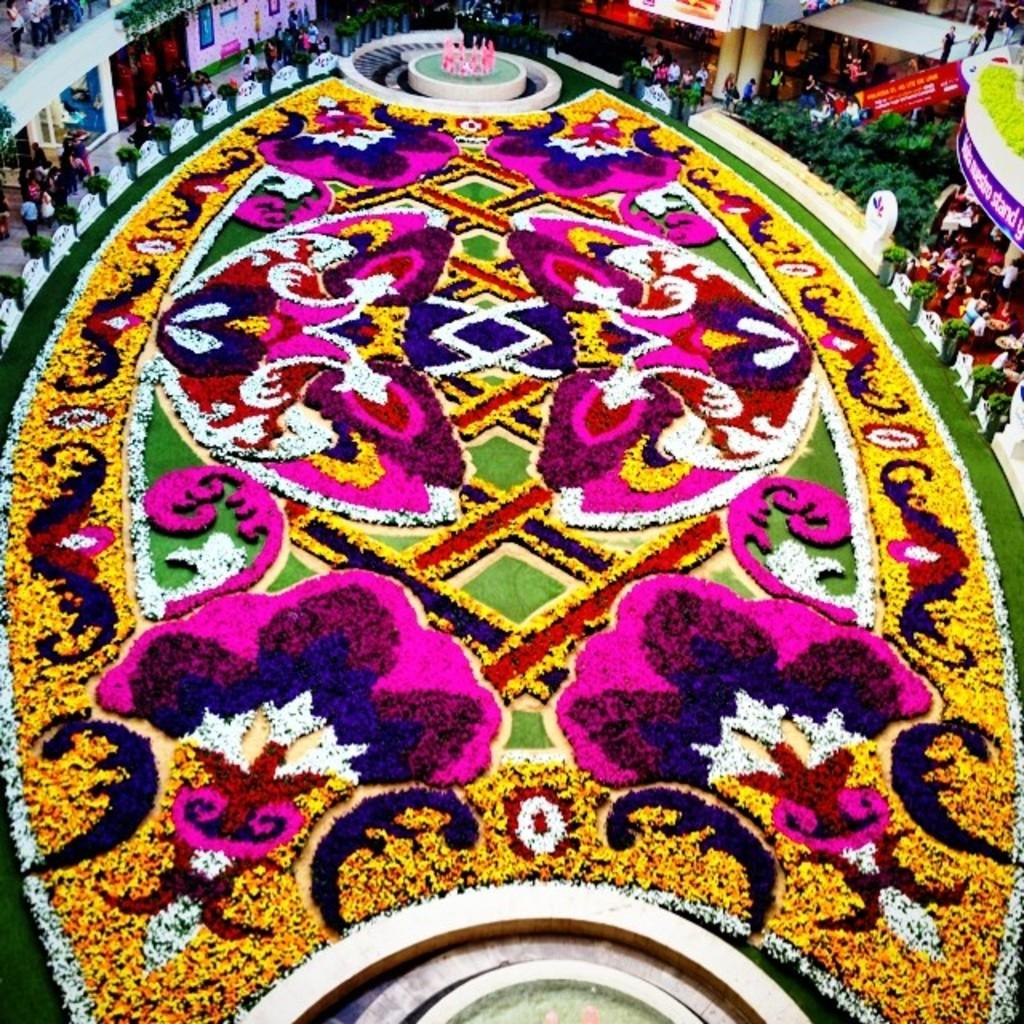What can be seen on the grass in the image? There is a design on the grass in the image. What type of water feature is present in the image? There are fountains in the image. What type of vegetation is present in the image? There are plants in the image. What type of decorative elements are present in the image? A: There are banners in the image. What type of architectural elements are present in the image? There are pillars in the image. What type of activity is happening in the image? There is a group of people on a path in the image. What type of objects are present in the image? There are some objects in the image. What type of silverware is present in the image? There is no silverware present in the image. What type of creamy substance is being used to decorate the banners in the image? There is no creamy substance being used to decorate the banners in the image. 